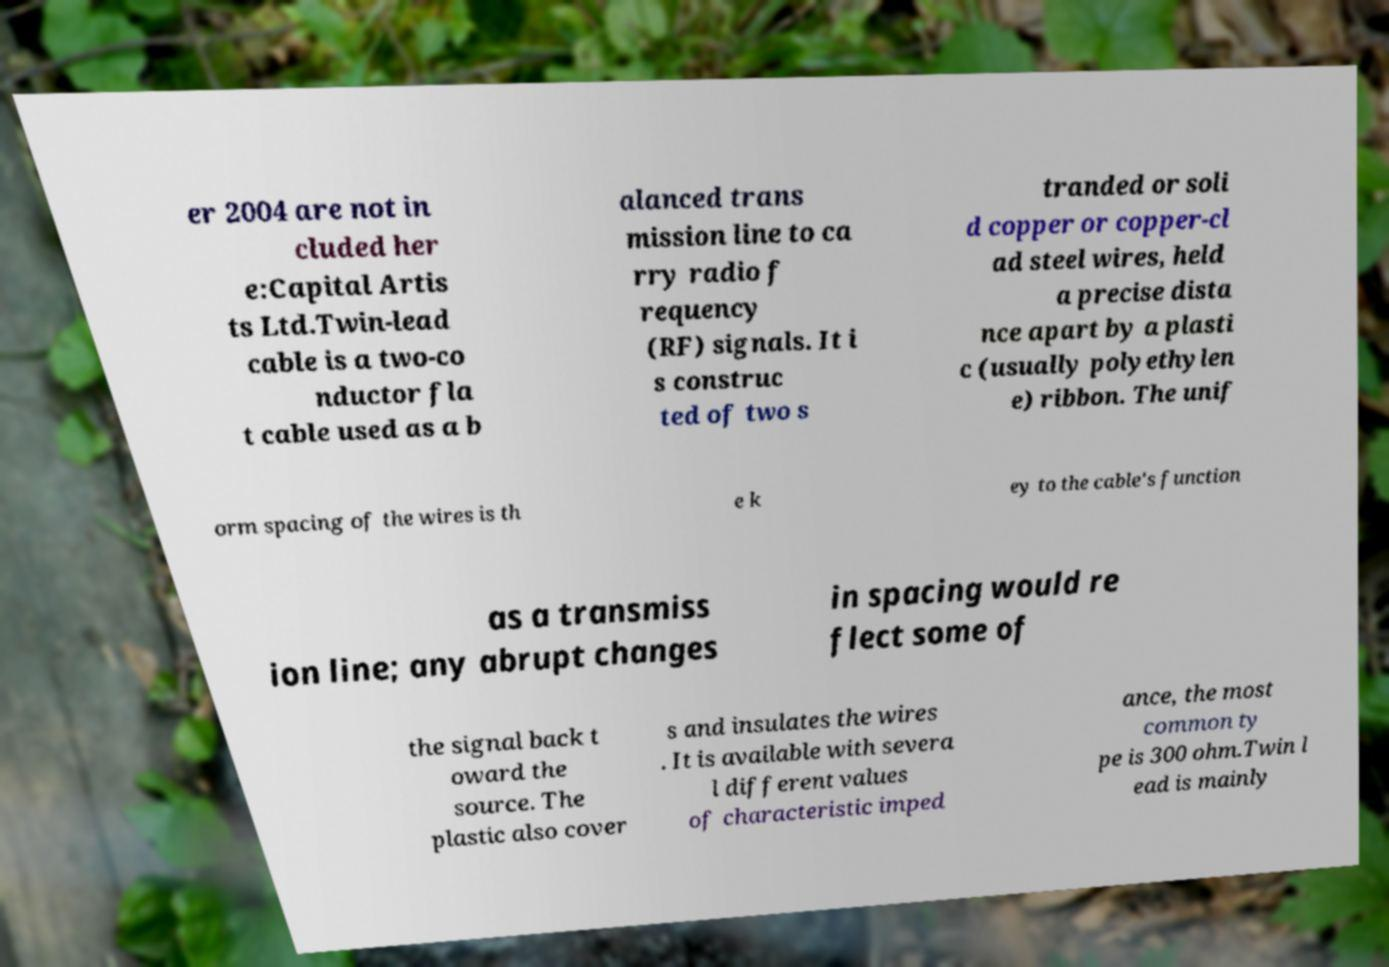Could you extract and type out the text from this image? er 2004 are not in cluded her e:Capital Artis ts Ltd.Twin-lead cable is a two-co nductor fla t cable used as a b alanced trans mission line to ca rry radio f requency (RF) signals. It i s construc ted of two s tranded or soli d copper or copper-cl ad steel wires, held a precise dista nce apart by a plasti c (usually polyethylen e) ribbon. The unif orm spacing of the wires is th e k ey to the cable's function as a transmiss ion line; any abrupt changes in spacing would re flect some of the signal back t oward the source. The plastic also cover s and insulates the wires . It is available with severa l different values of characteristic imped ance, the most common ty pe is 300 ohm.Twin l ead is mainly 